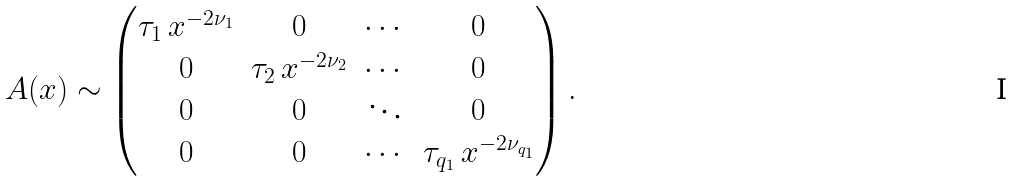<formula> <loc_0><loc_0><loc_500><loc_500>A ( x ) \sim \begin{pmatrix} \tau _ { 1 } \, x ^ { - 2 \nu _ { 1 } } & 0 & \cdots & 0 \\ 0 & \tau _ { 2 } \, x ^ { - 2 \nu _ { 2 } } & \cdots & 0 \\ 0 & 0 & \ddots & 0 \\ 0 & 0 & \cdots & \tau _ { q _ { 1 } } \, x ^ { - 2 \nu _ { q _ { 1 } } } \end{pmatrix} .</formula> 